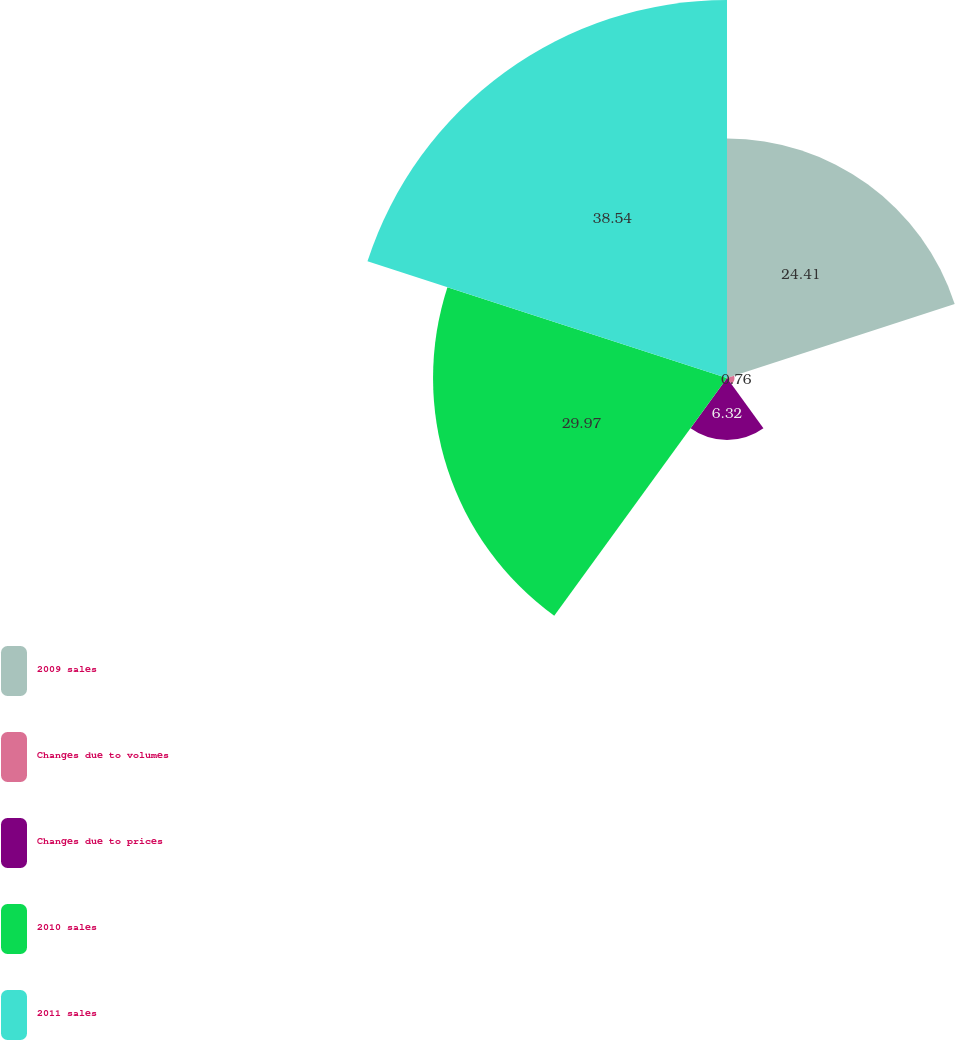Convert chart to OTSL. <chart><loc_0><loc_0><loc_500><loc_500><pie_chart><fcel>2009 sales<fcel>Changes due to volumes<fcel>Changes due to prices<fcel>2010 sales<fcel>2011 sales<nl><fcel>24.41%<fcel>0.76%<fcel>6.32%<fcel>29.97%<fcel>38.54%<nl></chart> 